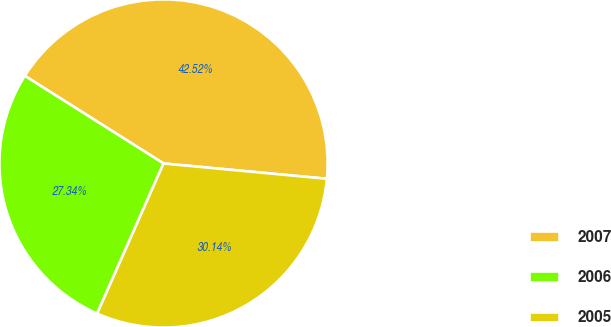Convert chart to OTSL. <chart><loc_0><loc_0><loc_500><loc_500><pie_chart><fcel>2007<fcel>2006<fcel>2005<nl><fcel>42.52%<fcel>27.34%<fcel>30.14%<nl></chart> 